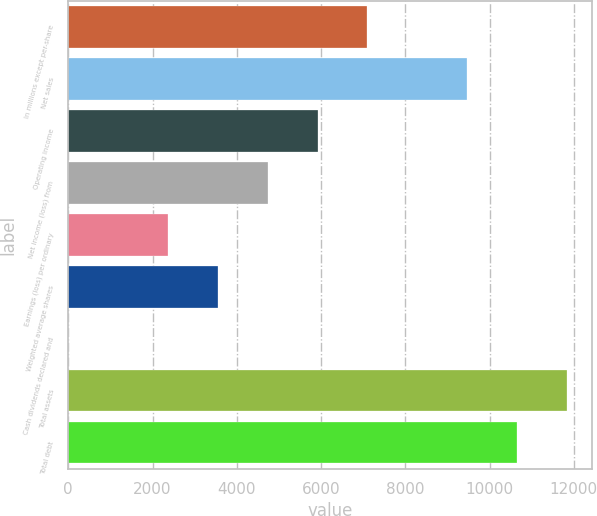Convert chart to OTSL. <chart><loc_0><loc_0><loc_500><loc_500><bar_chart><fcel>In millions except per-share<fcel>Net sales<fcel>Operating income<fcel>Net income (loss) from<fcel>Earnings (loss) per ordinary<fcel>Weighted average shares<fcel>Cash dividends declared and<fcel>Total assets<fcel>Total debt<nl><fcel>7100.25<fcel>9466.89<fcel>5916.93<fcel>4733.61<fcel>2366.97<fcel>3550.29<fcel>0.33<fcel>11833.5<fcel>10650.2<nl></chart> 